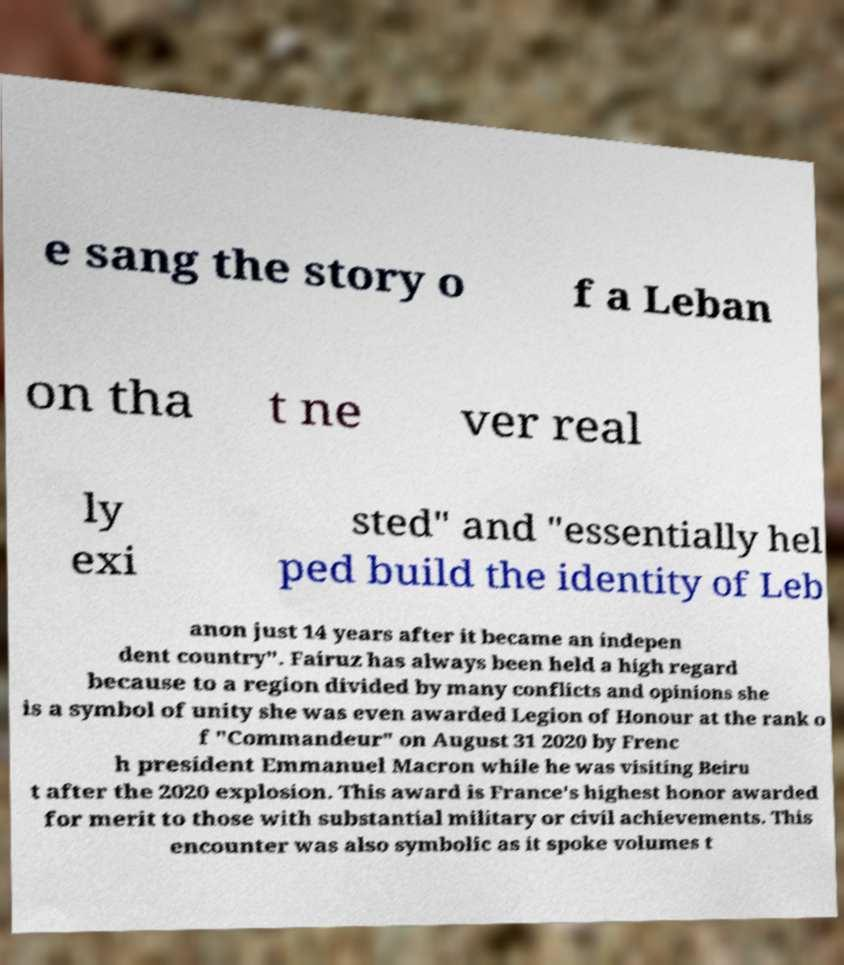Could you assist in decoding the text presented in this image and type it out clearly? e sang the story o f a Leban on tha t ne ver real ly exi sted" and "essentially hel ped build the identity of Leb anon just 14 years after it became an indepen dent country". Fairuz has always been held a high regard because to a region divided by many conflicts and opinions she is a symbol of unity she was even awarded Legion of Honour at the rank o f "Commandeur" on August 31 2020 by Frenc h president Emmanuel Macron while he was visiting Beiru t after the 2020 explosion. This award is France's highest honor awarded for merit to those with substantial military or civil achievements. This encounter was also symbolic as it spoke volumes t 